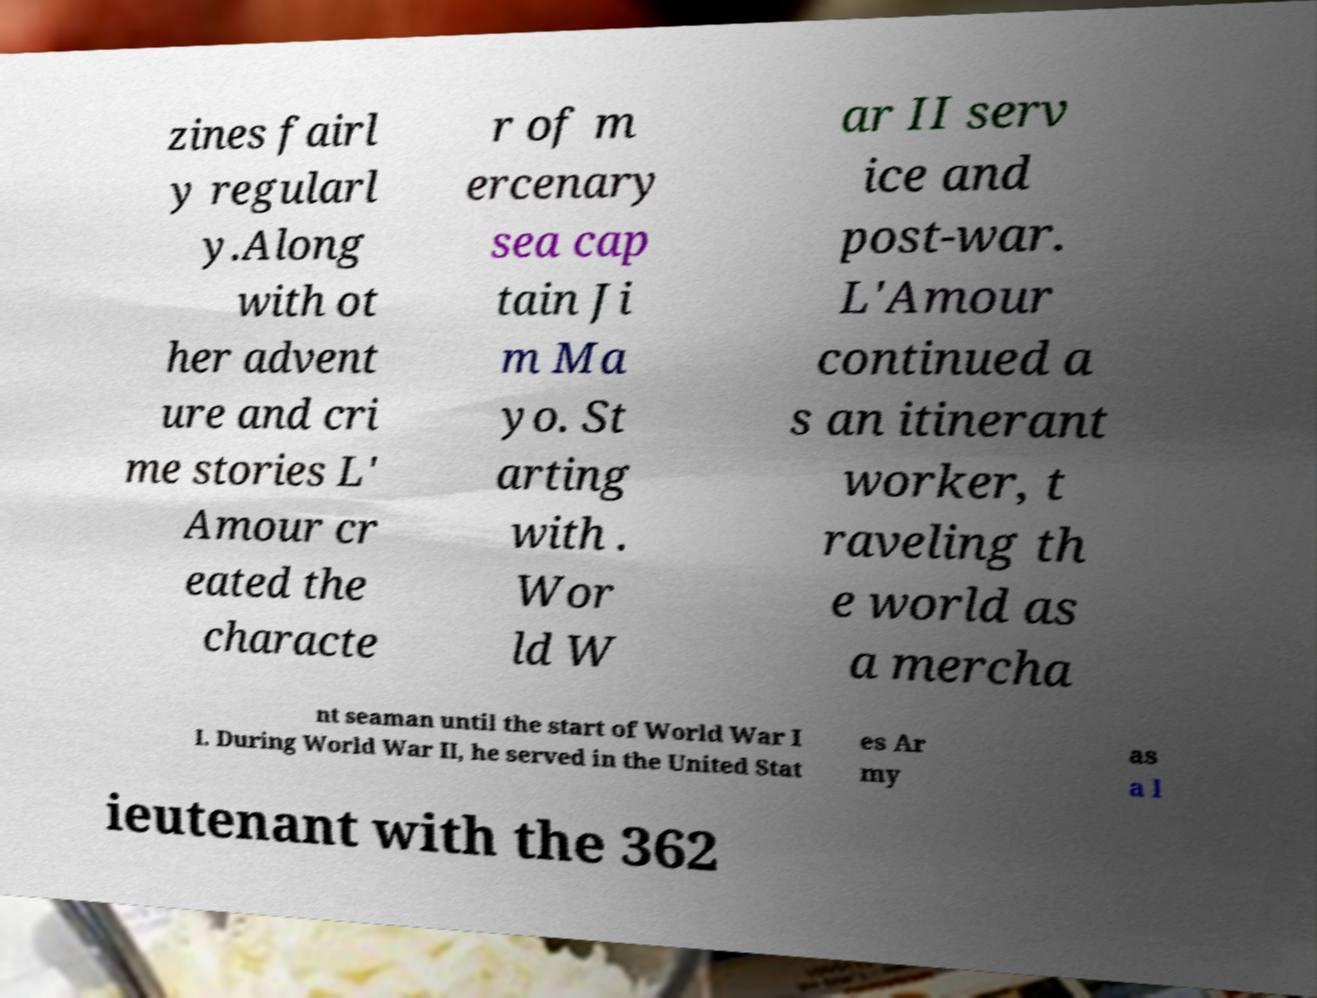What messages or text are displayed in this image? I need them in a readable, typed format. zines fairl y regularl y.Along with ot her advent ure and cri me stories L' Amour cr eated the characte r of m ercenary sea cap tain Ji m Ma yo. St arting with . Wor ld W ar II serv ice and post-war. L'Amour continued a s an itinerant worker, t raveling th e world as a mercha nt seaman until the start of World War I I. During World War II, he served in the United Stat es Ar my as a l ieutenant with the 362 